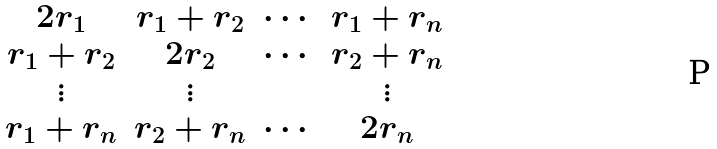Convert formula to latex. <formula><loc_0><loc_0><loc_500><loc_500>\begin{matrix} 2 r _ { 1 } & r _ { 1 } + r _ { 2 } & \cdots & r _ { 1 } + r _ { n } \\ r _ { 1 } + r _ { 2 } & 2 r _ { 2 } & \cdots & r _ { 2 } + r _ { n } \\ \vdots & \vdots & & \vdots \\ r _ { 1 } + r _ { n } & r _ { 2 } + r _ { n } & \cdots & 2 r _ { n } \end{matrix}</formula> 